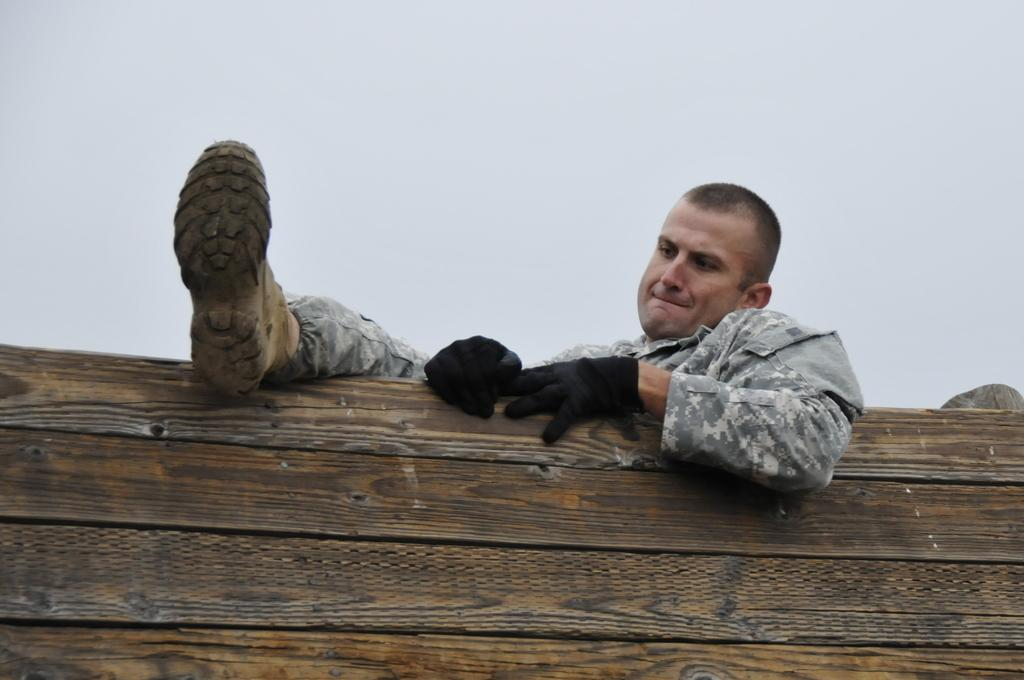What type of person is in the image? There is an army guy in the image. What protective gear is the army guy wearing? The army guy is wearing gloves and boots. What is the army guy attempting to do in the image? The army guy is trying to get above a wooden wall. What type of prison is visible in the image? There is no prison present in the image; it features an army guy trying to get above a wooden wall. What part of the army guy's face can be seen in the image? The image does not show the army guy's face, only his gloves, boots, and the wooden wall he is trying to get above. 